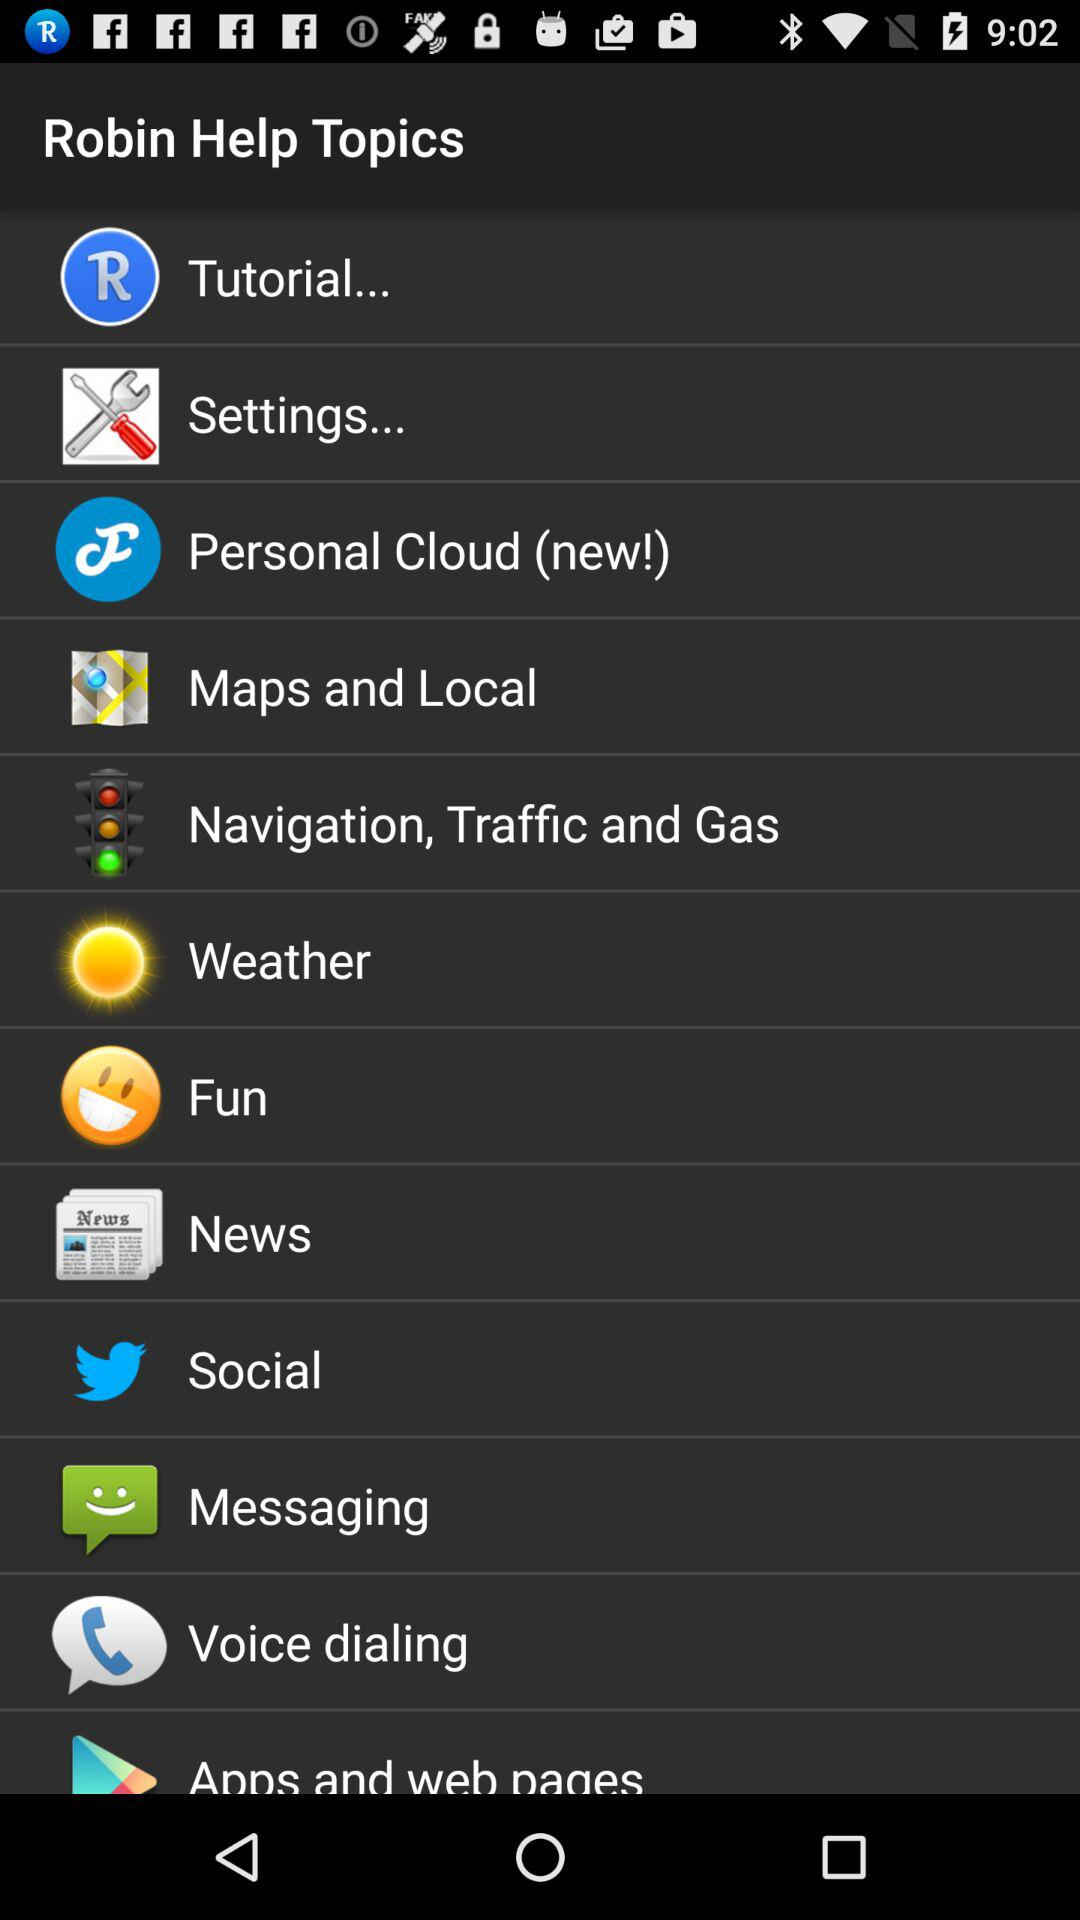How many notifications are there in "Messaging"?
When the provided information is insufficient, respond with <no answer>. <no answer> 